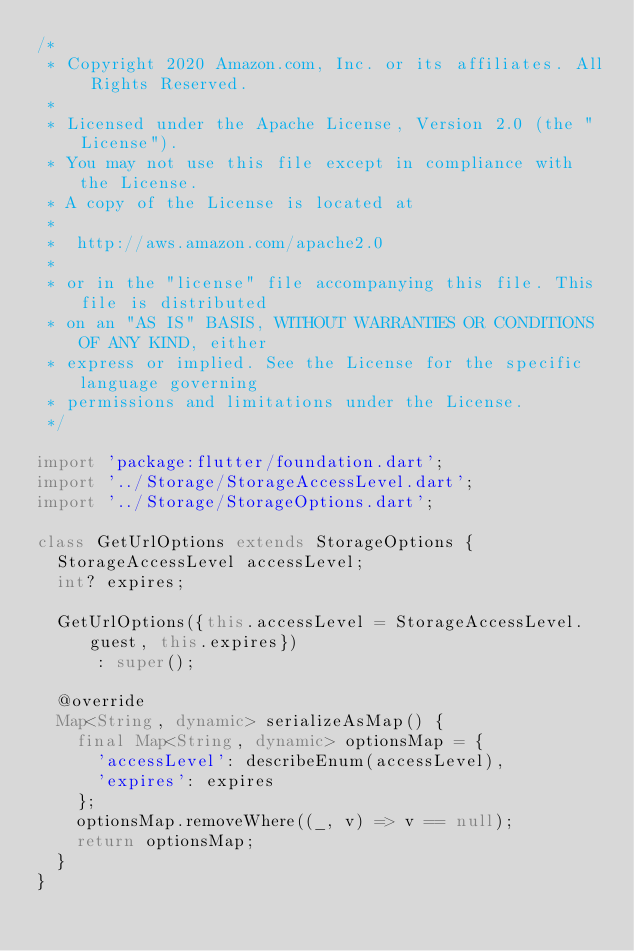<code> <loc_0><loc_0><loc_500><loc_500><_Dart_>/*
 * Copyright 2020 Amazon.com, Inc. or its affiliates. All Rights Reserved.
 *
 * Licensed under the Apache License, Version 2.0 (the "License").
 * You may not use this file except in compliance with the License.
 * A copy of the License is located at
 *
 *  http://aws.amazon.com/apache2.0
 *
 * or in the "license" file accompanying this file. This file is distributed
 * on an "AS IS" BASIS, WITHOUT WARRANTIES OR CONDITIONS OF ANY KIND, either
 * express or implied. See the License for the specific language governing
 * permissions and limitations under the License.
 */

import 'package:flutter/foundation.dart';
import '../Storage/StorageAccessLevel.dart';
import '../Storage/StorageOptions.dart';

class GetUrlOptions extends StorageOptions {
  StorageAccessLevel accessLevel;
  int? expires;

  GetUrlOptions({this.accessLevel = StorageAccessLevel.guest, this.expires})
      : super();

  @override
  Map<String, dynamic> serializeAsMap() {
    final Map<String, dynamic> optionsMap = {
      'accessLevel': describeEnum(accessLevel),
      'expires': expires
    };
    optionsMap.removeWhere((_, v) => v == null);
    return optionsMap;
  }
}
</code> 